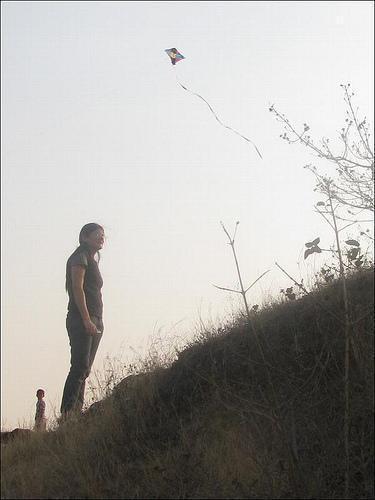How many people are watching?
Give a very brief answer. 1. 